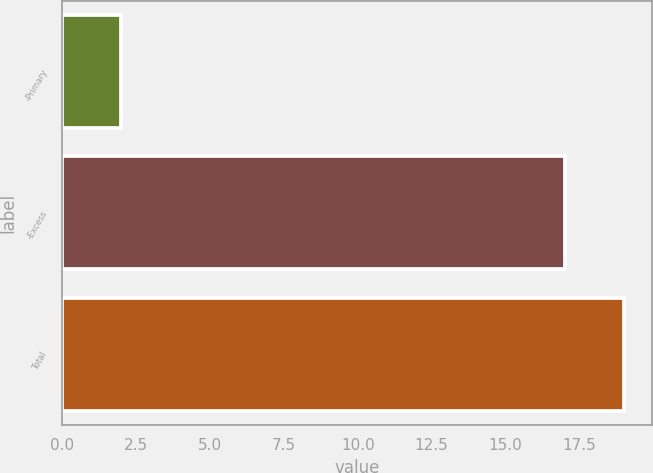Convert chart to OTSL. <chart><loc_0><loc_0><loc_500><loc_500><bar_chart><fcel>-Primary<fcel>-Excess<fcel>Total<nl><fcel>2<fcel>17<fcel>19<nl></chart> 